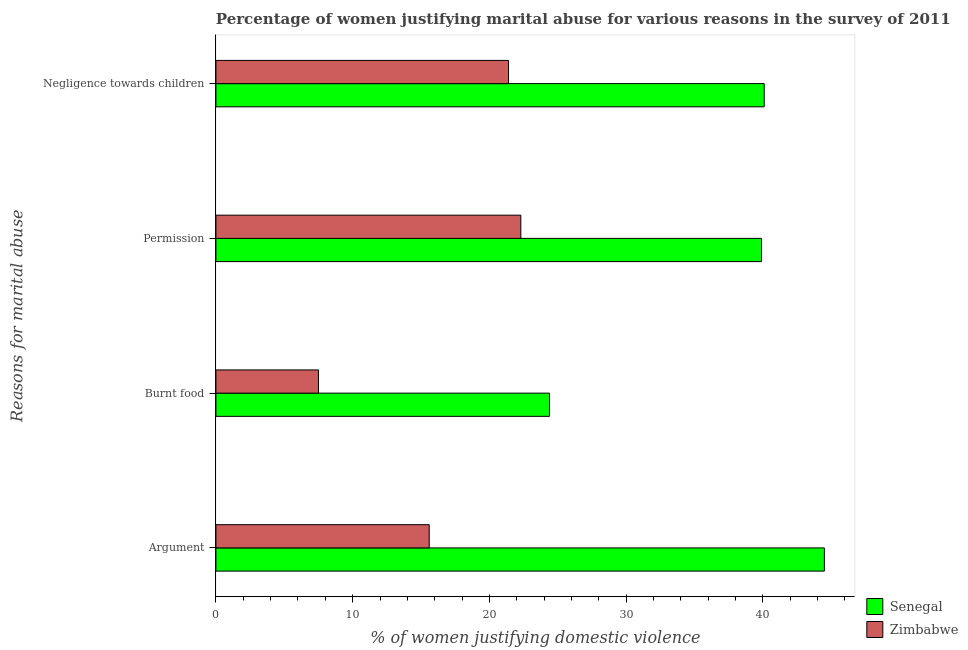Are the number of bars per tick equal to the number of legend labels?
Offer a terse response. Yes. What is the label of the 3rd group of bars from the top?
Provide a succinct answer. Burnt food. Across all countries, what is the maximum percentage of women justifying abuse for burning food?
Your response must be concise. 24.4. Across all countries, what is the minimum percentage of women justifying abuse for going without permission?
Your response must be concise. 22.3. In which country was the percentage of women justifying abuse in the case of an argument maximum?
Give a very brief answer. Senegal. In which country was the percentage of women justifying abuse for going without permission minimum?
Keep it short and to the point. Zimbabwe. What is the total percentage of women justifying abuse for showing negligence towards children in the graph?
Provide a succinct answer. 61.5. What is the difference between the percentage of women justifying abuse for going without permission in Senegal and that in Zimbabwe?
Give a very brief answer. 17.6. What is the difference between the percentage of women justifying abuse for burning food in Senegal and the percentage of women justifying abuse for showing negligence towards children in Zimbabwe?
Make the answer very short. 3. What is the average percentage of women justifying abuse for going without permission per country?
Keep it short and to the point. 31.1. What is the ratio of the percentage of women justifying abuse for showing negligence towards children in Senegal to that in Zimbabwe?
Make the answer very short. 1.87. Is the percentage of women justifying abuse for burning food in Senegal less than that in Zimbabwe?
Your answer should be very brief. No. What is the difference between the highest and the second highest percentage of women justifying abuse for going without permission?
Provide a succinct answer. 17.6. What is the difference between the highest and the lowest percentage of women justifying abuse for burning food?
Make the answer very short. 16.9. Is it the case that in every country, the sum of the percentage of women justifying abuse for going without permission and percentage of women justifying abuse for burning food is greater than the sum of percentage of women justifying abuse in the case of an argument and percentage of women justifying abuse for showing negligence towards children?
Your response must be concise. No. What does the 1st bar from the top in Negligence towards children represents?
Your response must be concise. Zimbabwe. What does the 1st bar from the bottom in Permission represents?
Offer a terse response. Senegal. Is it the case that in every country, the sum of the percentage of women justifying abuse in the case of an argument and percentage of women justifying abuse for burning food is greater than the percentage of women justifying abuse for going without permission?
Ensure brevity in your answer.  Yes. How many bars are there?
Provide a succinct answer. 8. Are the values on the major ticks of X-axis written in scientific E-notation?
Your answer should be compact. No. Does the graph contain grids?
Your answer should be compact. No. How many legend labels are there?
Keep it short and to the point. 2. What is the title of the graph?
Ensure brevity in your answer.  Percentage of women justifying marital abuse for various reasons in the survey of 2011. Does "Ukraine" appear as one of the legend labels in the graph?
Keep it short and to the point. No. What is the label or title of the X-axis?
Ensure brevity in your answer.  % of women justifying domestic violence. What is the label or title of the Y-axis?
Make the answer very short. Reasons for marital abuse. What is the % of women justifying domestic violence in Senegal in Argument?
Provide a short and direct response. 44.5. What is the % of women justifying domestic violence in Senegal in Burnt food?
Make the answer very short. 24.4. What is the % of women justifying domestic violence in Zimbabwe in Burnt food?
Provide a short and direct response. 7.5. What is the % of women justifying domestic violence in Senegal in Permission?
Ensure brevity in your answer.  39.9. What is the % of women justifying domestic violence in Zimbabwe in Permission?
Your answer should be very brief. 22.3. What is the % of women justifying domestic violence of Senegal in Negligence towards children?
Offer a terse response. 40.1. What is the % of women justifying domestic violence in Zimbabwe in Negligence towards children?
Offer a very short reply. 21.4. Across all Reasons for marital abuse, what is the maximum % of women justifying domestic violence in Senegal?
Make the answer very short. 44.5. Across all Reasons for marital abuse, what is the maximum % of women justifying domestic violence in Zimbabwe?
Offer a terse response. 22.3. Across all Reasons for marital abuse, what is the minimum % of women justifying domestic violence in Senegal?
Ensure brevity in your answer.  24.4. Across all Reasons for marital abuse, what is the minimum % of women justifying domestic violence in Zimbabwe?
Your response must be concise. 7.5. What is the total % of women justifying domestic violence of Senegal in the graph?
Offer a terse response. 148.9. What is the total % of women justifying domestic violence of Zimbabwe in the graph?
Ensure brevity in your answer.  66.8. What is the difference between the % of women justifying domestic violence of Senegal in Argument and that in Burnt food?
Provide a short and direct response. 20.1. What is the difference between the % of women justifying domestic violence of Senegal in Argument and that in Permission?
Provide a short and direct response. 4.6. What is the difference between the % of women justifying domestic violence of Zimbabwe in Argument and that in Permission?
Give a very brief answer. -6.7. What is the difference between the % of women justifying domestic violence in Senegal in Argument and that in Negligence towards children?
Give a very brief answer. 4.4. What is the difference between the % of women justifying domestic violence of Senegal in Burnt food and that in Permission?
Keep it short and to the point. -15.5. What is the difference between the % of women justifying domestic violence in Zimbabwe in Burnt food and that in Permission?
Keep it short and to the point. -14.8. What is the difference between the % of women justifying domestic violence of Senegal in Burnt food and that in Negligence towards children?
Provide a short and direct response. -15.7. What is the difference between the % of women justifying domestic violence of Zimbabwe in Burnt food and that in Negligence towards children?
Your answer should be very brief. -13.9. What is the difference between the % of women justifying domestic violence in Senegal in Permission and that in Negligence towards children?
Offer a very short reply. -0.2. What is the difference between the % of women justifying domestic violence in Zimbabwe in Permission and that in Negligence towards children?
Ensure brevity in your answer.  0.9. What is the difference between the % of women justifying domestic violence in Senegal in Argument and the % of women justifying domestic violence in Zimbabwe in Permission?
Your answer should be compact. 22.2. What is the difference between the % of women justifying domestic violence of Senegal in Argument and the % of women justifying domestic violence of Zimbabwe in Negligence towards children?
Offer a very short reply. 23.1. What is the difference between the % of women justifying domestic violence of Senegal in Burnt food and the % of women justifying domestic violence of Zimbabwe in Negligence towards children?
Make the answer very short. 3. What is the average % of women justifying domestic violence in Senegal per Reasons for marital abuse?
Provide a short and direct response. 37.23. What is the average % of women justifying domestic violence in Zimbabwe per Reasons for marital abuse?
Your answer should be compact. 16.7. What is the difference between the % of women justifying domestic violence of Senegal and % of women justifying domestic violence of Zimbabwe in Argument?
Make the answer very short. 28.9. What is the ratio of the % of women justifying domestic violence in Senegal in Argument to that in Burnt food?
Your answer should be compact. 1.82. What is the ratio of the % of women justifying domestic violence of Zimbabwe in Argument to that in Burnt food?
Your answer should be very brief. 2.08. What is the ratio of the % of women justifying domestic violence in Senegal in Argument to that in Permission?
Provide a short and direct response. 1.12. What is the ratio of the % of women justifying domestic violence of Zimbabwe in Argument to that in Permission?
Provide a short and direct response. 0.7. What is the ratio of the % of women justifying domestic violence in Senegal in Argument to that in Negligence towards children?
Ensure brevity in your answer.  1.11. What is the ratio of the % of women justifying domestic violence in Zimbabwe in Argument to that in Negligence towards children?
Ensure brevity in your answer.  0.73. What is the ratio of the % of women justifying domestic violence in Senegal in Burnt food to that in Permission?
Provide a short and direct response. 0.61. What is the ratio of the % of women justifying domestic violence in Zimbabwe in Burnt food to that in Permission?
Keep it short and to the point. 0.34. What is the ratio of the % of women justifying domestic violence in Senegal in Burnt food to that in Negligence towards children?
Your answer should be very brief. 0.61. What is the ratio of the % of women justifying domestic violence in Zimbabwe in Burnt food to that in Negligence towards children?
Give a very brief answer. 0.35. What is the ratio of the % of women justifying domestic violence in Senegal in Permission to that in Negligence towards children?
Offer a terse response. 0.99. What is the ratio of the % of women justifying domestic violence in Zimbabwe in Permission to that in Negligence towards children?
Ensure brevity in your answer.  1.04. What is the difference between the highest and the second highest % of women justifying domestic violence in Senegal?
Your response must be concise. 4.4. What is the difference between the highest and the lowest % of women justifying domestic violence in Senegal?
Your response must be concise. 20.1. 